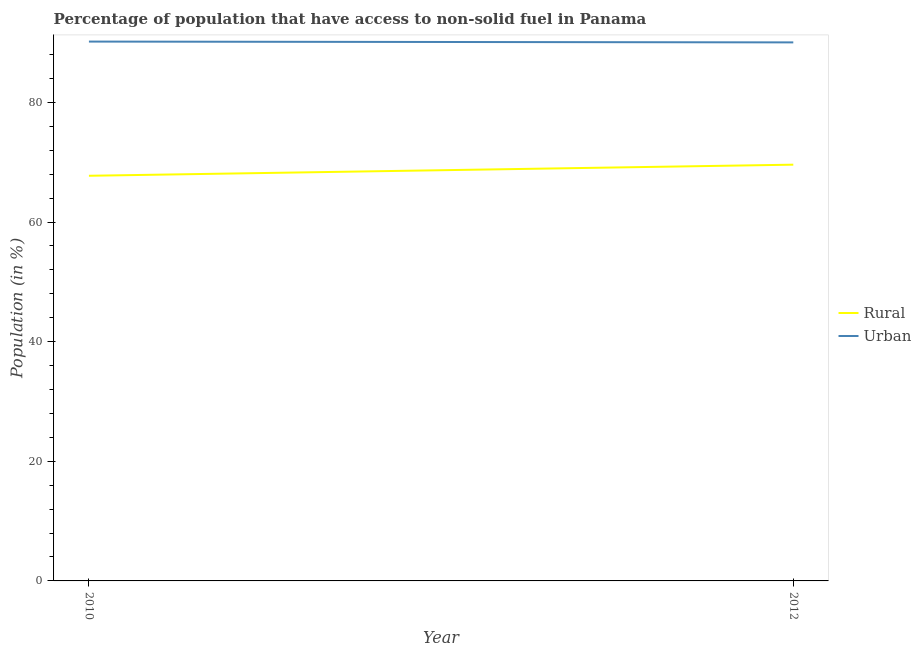How many different coloured lines are there?
Your answer should be compact. 2. Does the line corresponding to rural population intersect with the line corresponding to urban population?
Provide a succinct answer. No. Is the number of lines equal to the number of legend labels?
Make the answer very short. Yes. What is the rural population in 2012?
Make the answer very short. 69.59. Across all years, what is the maximum rural population?
Provide a succinct answer. 69.59. Across all years, what is the minimum urban population?
Give a very brief answer. 90.03. In which year was the rural population maximum?
Provide a short and direct response. 2012. What is the total urban population in the graph?
Your answer should be compact. 180.19. What is the difference between the urban population in 2010 and that in 2012?
Provide a short and direct response. 0.14. What is the difference between the urban population in 2012 and the rural population in 2010?
Give a very brief answer. 22.3. What is the average urban population per year?
Your response must be concise. 90.1. In the year 2010, what is the difference between the urban population and rural population?
Keep it short and to the point. 22.43. In how many years, is the rural population greater than 4 %?
Your answer should be very brief. 2. What is the ratio of the rural population in 2010 to that in 2012?
Offer a very short reply. 0.97. Is the urban population strictly less than the rural population over the years?
Keep it short and to the point. No. What is the difference between two consecutive major ticks on the Y-axis?
Offer a terse response. 20. Does the graph contain any zero values?
Keep it short and to the point. No. Does the graph contain grids?
Keep it short and to the point. No. Where does the legend appear in the graph?
Provide a short and direct response. Center right. How are the legend labels stacked?
Your response must be concise. Vertical. What is the title of the graph?
Ensure brevity in your answer.  Percentage of population that have access to non-solid fuel in Panama. What is the label or title of the Y-axis?
Your response must be concise. Population (in %). What is the Population (in %) of Rural in 2010?
Provide a succinct answer. 67.73. What is the Population (in %) in Urban in 2010?
Give a very brief answer. 90.17. What is the Population (in %) of Rural in 2012?
Ensure brevity in your answer.  69.59. What is the Population (in %) of Urban in 2012?
Give a very brief answer. 90.03. Across all years, what is the maximum Population (in %) in Rural?
Your answer should be compact. 69.59. Across all years, what is the maximum Population (in %) in Urban?
Offer a terse response. 90.17. Across all years, what is the minimum Population (in %) in Rural?
Ensure brevity in your answer.  67.73. Across all years, what is the minimum Population (in %) of Urban?
Your answer should be compact. 90.03. What is the total Population (in %) of Rural in the graph?
Keep it short and to the point. 137.32. What is the total Population (in %) of Urban in the graph?
Give a very brief answer. 180.19. What is the difference between the Population (in %) of Rural in 2010 and that in 2012?
Your answer should be very brief. -1.85. What is the difference between the Population (in %) of Urban in 2010 and that in 2012?
Offer a very short reply. 0.14. What is the difference between the Population (in %) in Rural in 2010 and the Population (in %) in Urban in 2012?
Provide a short and direct response. -22.3. What is the average Population (in %) of Rural per year?
Offer a very short reply. 68.66. What is the average Population (in %) of Urban per year?
Offer a very short reply. 90.1. In the year 2010, what is the difference between the Population (in %) of Rural and Population (in %) of Urban?
Keep it short and to the point. -22.43. In the year 2012, what is the difference between the Population (in %) in Rural and Population (in %) in Urban?
Offer a terse response. -20.44. What is the ratio of the Population (in %) in Rural in 2010 to that in 2012?
Offer a terse response. 0.97. What is the ratio of the Population (in %) in Urban in 2010 to that in 2012?
Ensure brevity in your answer.  1. What is the difference between the highest and the second highest Population (in %) in Rural?
Offer a very short reply. 1.85. What is the difference between the highest and the second highest Population (in %) of Urban?
Your response must be concise. 0.14. What is the difference between the highest and the lowest Population (in %) in Rural?
Provide a short and direct response. 1.85. What is the difference between the highest and the lowest Population (in %) in Urban?
Give a very brief answer. 0.14. 